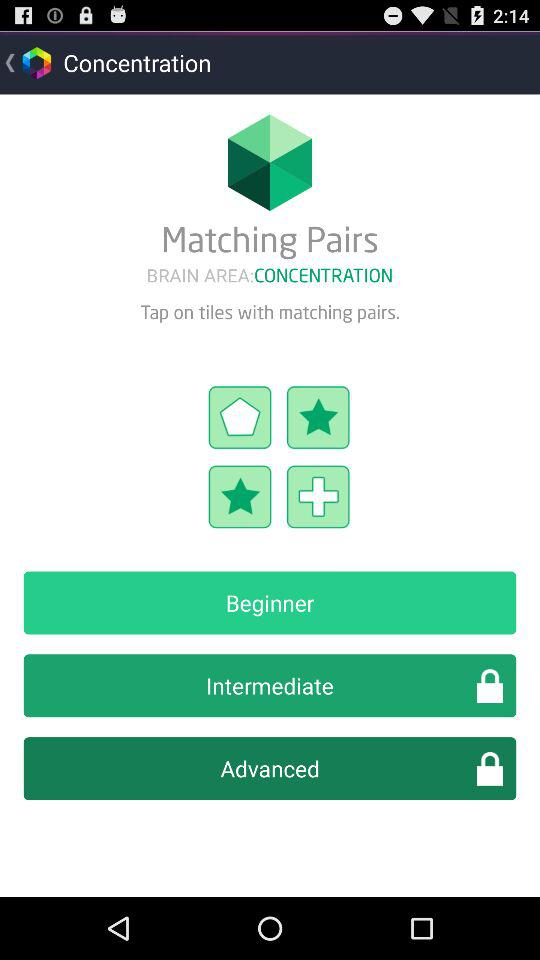How many levels are there in total?
Answer the question using a single word or phrase. 3 